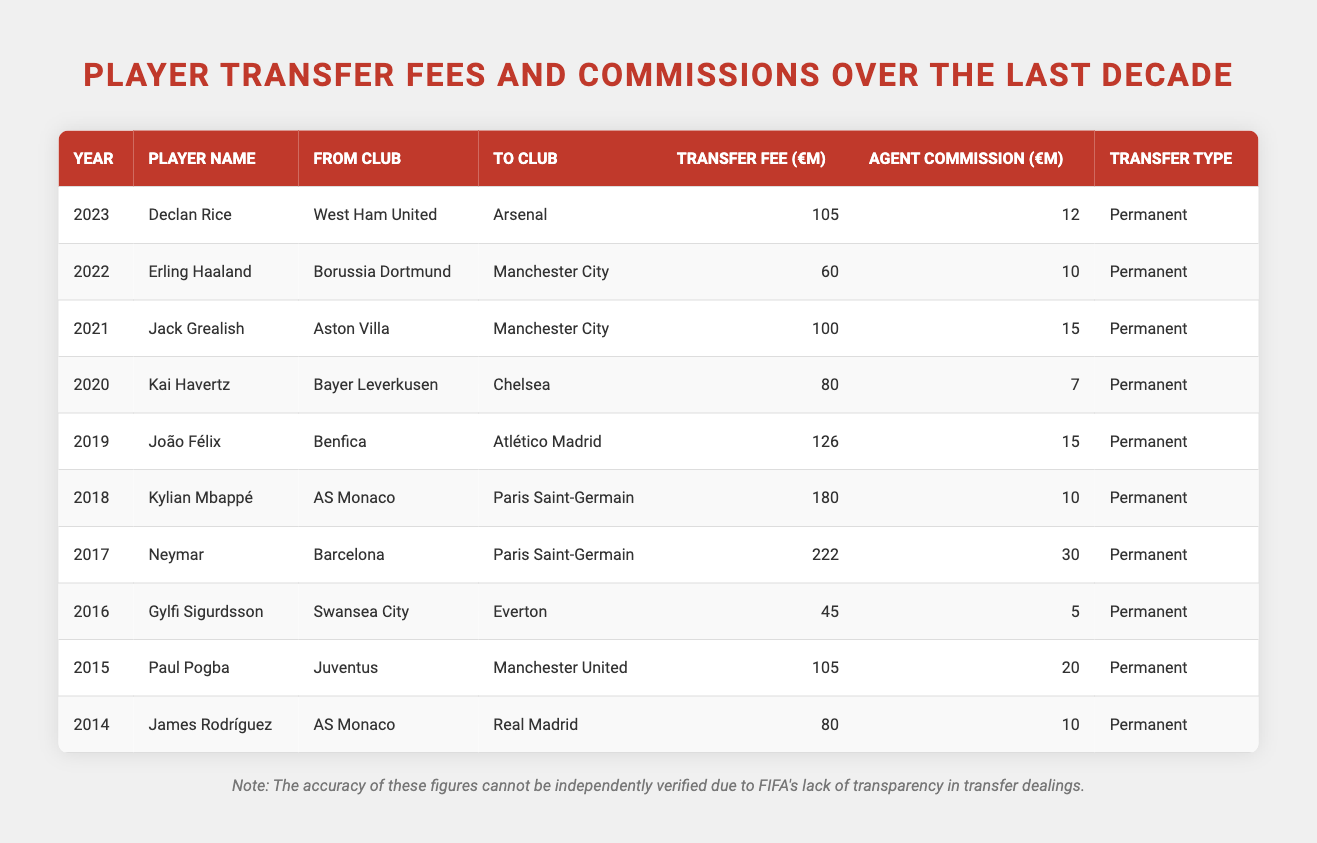What was the transfer fee for Neymar? The table shows that Neymar was transferred in 2017 for a fee of 222 million euros.
Answer: 222 million Which player had the highest agent commission? By looking at the table, Neymar had the highest agent commission of 30 million euros in 2017.
Answer: 30 million How much did Paul Pogba's transfer fee exceed that of James Rodríguez? Paul Pogba's transfer fee was 105 million euros, while James Rodríguez's was 80 million euros. The difference is 105 - 80 = 25 million euros.
Answer: 25 million What is the average transfer fee for players transferred to Manchester City? The players transferred to Manchester City are Jack Grealish (100 million) and Erling Haaland (60 million). The average is (100 + 60) / 2 = 80 million euros.
Answer: 80 million What is the total sum of agent commissions for the players transferred in 2022 and 2023? The agent commission for Erling Haaland in 2022 is 10 million euros and for Declan Rice in 2023 is 12 million euros. The total is 10 + 12 = 22 million euros.
Answer: 22 million Which year saw a transfer fee of more than 200 million euros? Referring to the table, the year 2017 saw a transfer fee of 222 million euros for Neymar, making it the only year over 200 million.
Answer: 2017 Was the transfer fee for Kylian Mbappé higher or lower than that of João Félix? Kylian Mbappé's transfer fee was 180 million euros, and João Félix's was 126 million euros. Since 180 is greater than 126, the transfer fee for Mbappé was higher.
Answer: Higher How many players had a transfer fee greater than 100 million euros? The players with fees greater than 100 million euros are Paul Pogba (105), Neymar (222), Kylian Mbappé (180), and João Félix (126) - a total of 4 players.
Answer: 4 What is the difference in transfer fees between the highest and the lowest transfer fees on the table? The highest transfer fee is Neymar's at 222 million euros, and the lowest is Gylfi Sigurdsson's at 45 million euros. Therefore, the difference is 222 - 45 = 177 million euros.
Answer: 177 million Which club received the highest transfer fee, and how much was it? The highest transfer fee was received by Barcelona for Neymar, totaling 222 million euros in 2017.
Answer: Barcelona, 222 million 